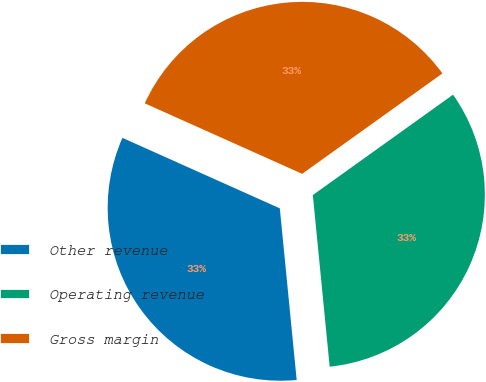Convert chart. <chart><loc_0><loc_0><loc_500><loc_500><pie_chart><fcel>Other revenue<fcel>Operating revenue<fcel>Gross margin<nl><fcel>33.26%<fcel>33.33%<fcel>33.41%<nl></chart> 